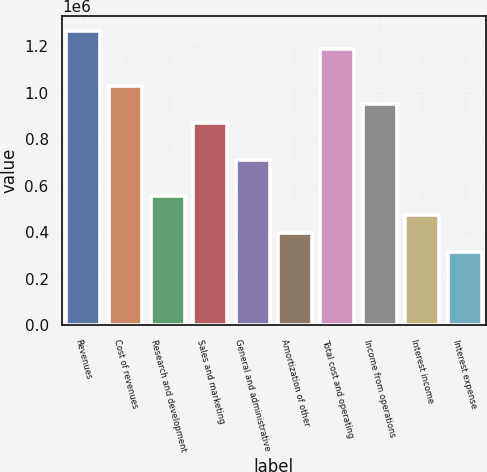Convert chart to OTSL. <chart><loc_0><loc_0><loc_500><loc_500><bar_chart><fcel>Revenues<fcel>Cost of revenues<fcel>Research and development<fcel>Sales and marketing<fcel>General and administrative<fcel>Amortization of other<fcel>Total cost and operating<fcel>Income from operations<fcel>Interest income<fcel>Interest expense<nl><fcel>1.26548e+06<fcel>1.0282e+06<fcel>553647<fcel>870016<fcel>711832<fcel>395462<fcel>1.18639e+06<fcel>949109<fcel>474555<fcel>316370<nl></chart> 